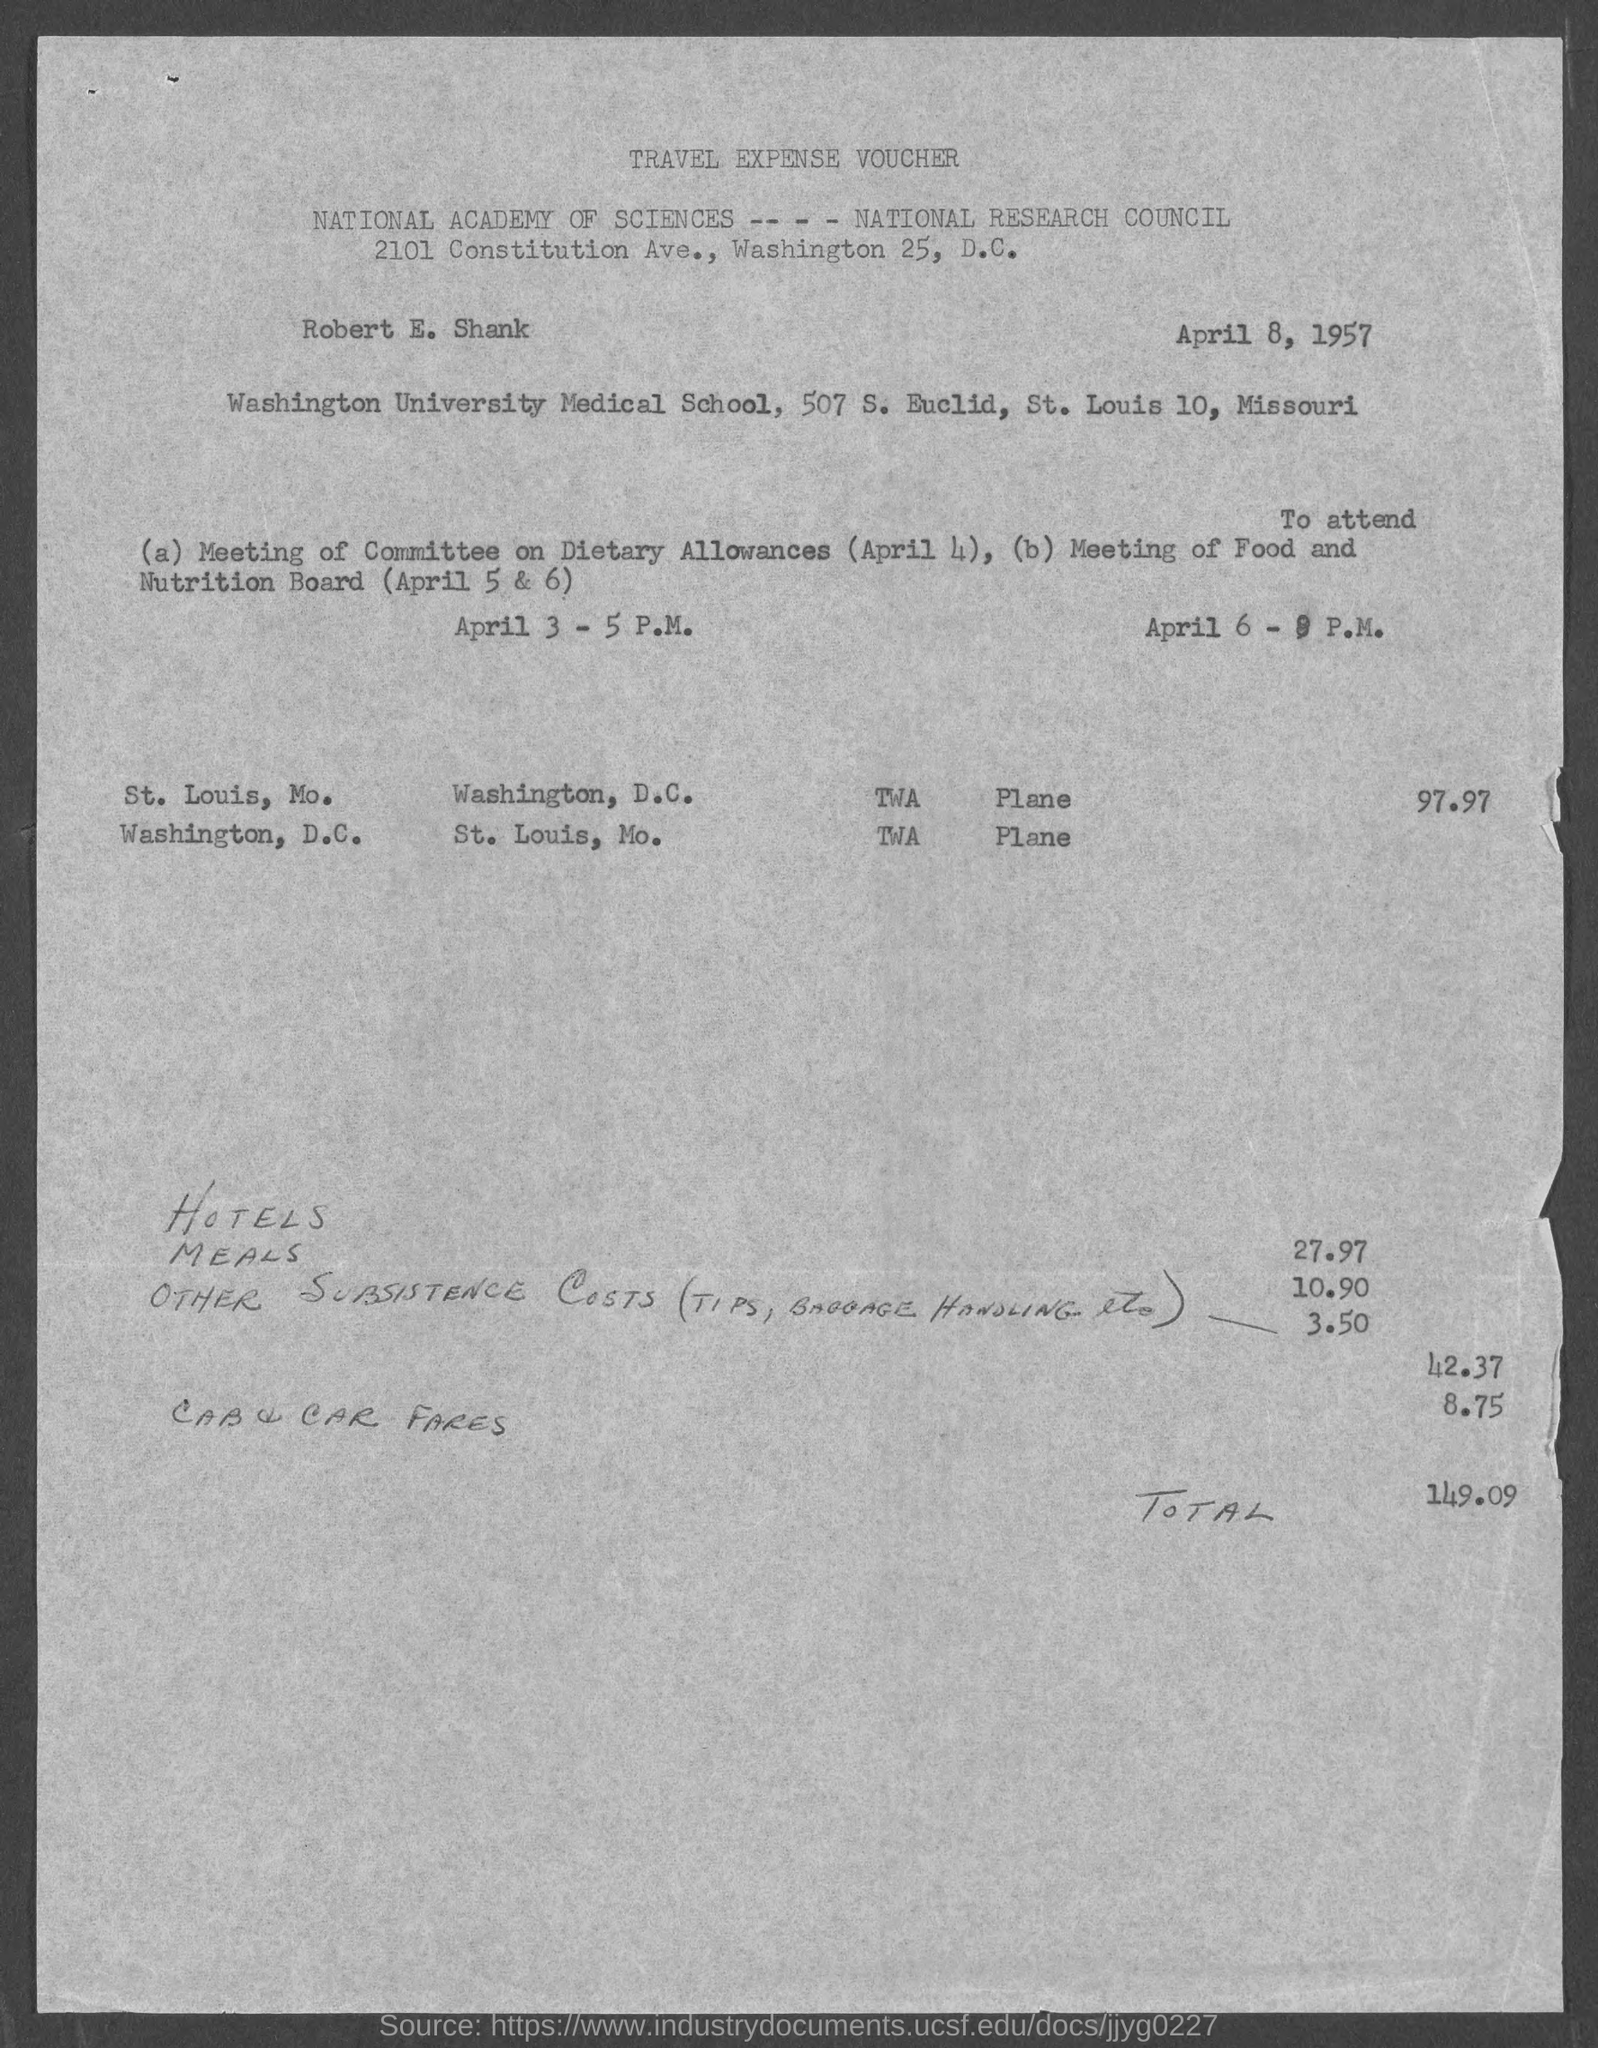Give some essential details in this illustration. The name of the person mentioned in the voucher is Robert E. Shank. The voucher was issued on April 8, 1957. The voucher mentions other subsistence costs of 3.50... The total travel expense mentioned in the voucher is 149.09. The Meeting of Food and Nutrition Board will be held on April 5 and 6. 